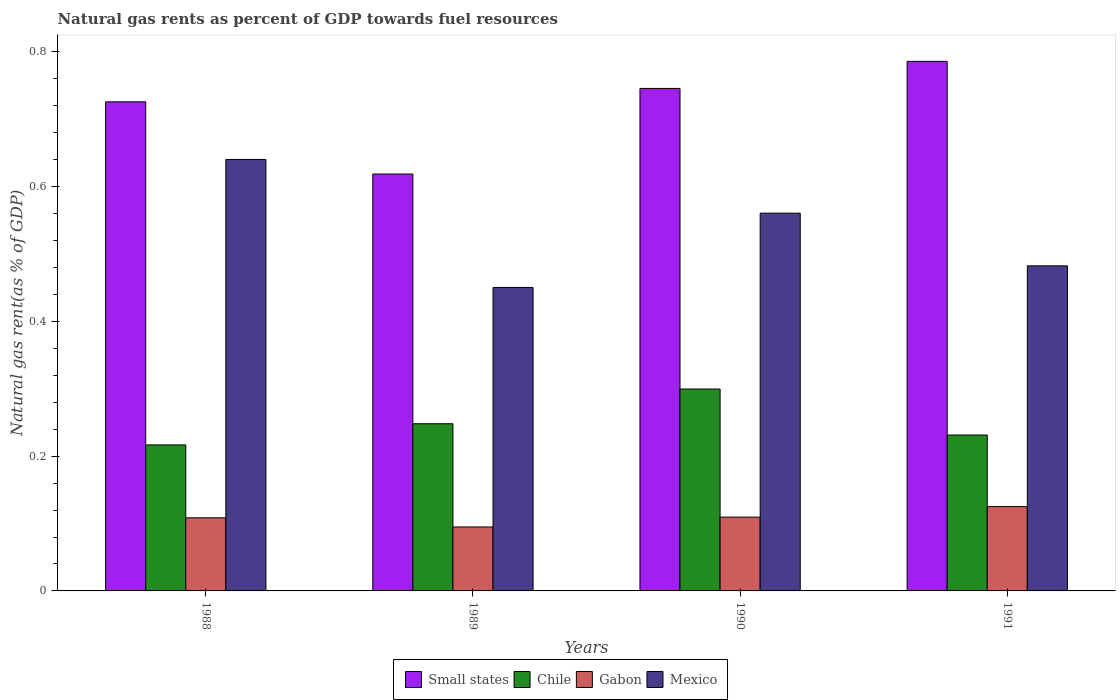How many different coloured bars are there?
Make the answer very short. 4. Are the number of bars per tick equal to the number of legend labels?
Provide a short and direct response. Yes. Are the number of bars on each tick of the X-axis equal?
Your answer should be compact. Yes. How many bars are there on the 2nd tick from the right?
Make the answer very short. 4. What is the natural gas rent in Chile in 1991?
Offer a terse response. 0.23. Across all years, what is the maximum natural gas rent in Mexico?
Your response must be concise. 0.64. Across all years, what is the minimum natural gas rent in Gabon?
Provide a succinct answer. 0.09. In which year was the natural gas rent in Gabon maximum?
Your response must be concise. 1991. In which year was the natural gas rent in Gabon minimum?
Give a very brief answer. 1989. What is the total natural gas rent in Gabon in the graph?
Your answer should be very brief. 0.44. What is the difference between the natural gas rent in Mexico in 1988 and that in 1991?
Your response must be concise. 0.16. What is the difference between the natural gas rent in Small states in 1989 and the natural gas rent in Gabon in 1990?
Offer a very short reply. 0.51. What is the average natural gas rent in Small states per year?
Ensure brevity in your answer.  0.72. In the year 1988, what is the difference between the natural gas rent in Small states and natural gas rent in Chile?
Offer a very short reply. 0.51. In how many years, is the natural gas rent in Chile greater than 0.24000000000000002 %?
Provide a short and direct response. 2. What is the ratio of the natural gas rent in Chile in 1989 to that in 1990?
Offer a very short reply. 0.83. Is the natural gas rent in Gabon in 1988 less than that in 1990?
Your response must be concise. Yes. Is the difference between the natural gas rent in Small states in 1990 and 1991 greater than the difference between the natural gas rent in Chile in 1990 and 1991?
Your response must be concise. No. What is the difference between the highest and the second highest natural gas rent in Mexico?
Give a very brief answer. 0.08. What is the difference between the highest and the lowest natural gas rent in Small states?
Your response must be concise. 0.17. Is the sum of the natural gas rent in Chile in 1990 and 1991 greater than the maximum natural gas rent in Gabon across all years?
Your answer should be compact. Yes. What does the 4th bar from the left in 1989 represents?
Ensure brevity in your answer.  Mexico. What does the 2nd bar from the right in 1988 represents?
Your response must be concise. Gabon. Is it the case that in every year, the sum of the natural gas rent in Chile and natural gas rent in Small states is greater than the natural gas rent in Mexico?
Keep it short and to the point. Yes. Where does the legend appear in the graph?
Give a very brief answer. Bottom center. How many legend labels are there?
Your response must be concise. 4. What is the title of the graph?
Give a very brief answer. Natural gas rents as percent of GDP towards fuel resources. What is the label or title of the Y-axis?
Make the answer very short. Natural gas rent(as % of GDP). What is the Natural gas rent(as % of GDP) of Small states in 1988?
Your answer should be very brief. 0.73. What is the Natural gas rent(as % of GDP) of Chile in 1988?
Provide a succinct answer. 0.22. What is the Natural gas rent(as % of GDP) in Gabon in 1988?
Your response must be concise. 0.11. What is the Natural gas rent(as % of GDP) of Mexico in 1988?
Provide a short and direct response. 0.64. What is the Natural gas rent(as % of GDP) of Small states in 1989?
Give a very brief answer. 0.62. What is the Natural gas rent(as % of GDP) in Chile in 1989?
Provide a succinct answer. 0.25. What is the Natural gas rent(as % of GDP) in Gabon in 1989?
Provide a short and direct response. 0.09. What is the Natural gas rent(as % of GDP) of Mexico in 1989?
Offer a very short reply. 0.45. What is the Natural gas rent(as % of GDP) of Small states in 1990?
Offer a terse response. 0.75. What is the Natural gas rent(as % of GDP) in Chile in 1990?
Give a very brief answer. 0.3. What is the Natural gas rent(as % of GDP) of Gabon in 1990?
Your answer should be compact. 0.11. What is the Natural gas rent(as % of GDP) in Mexico in 1990?
Make the answer very short. 0.56. What is the Natural gas rent(as % of GDP) in Small states in 1991?
Your answer should be very brief. 0.79. What is the Natural gas rent(as % of GDP) of Chile in 1991?
Provide a succinct answer. 0.23. What is the Natural gas rent(as % of GDP) of Gabon in 1991?
Your response must be concise. 0.13. What is the Natural gas rent(as % of GDP) in Mexico in 1991?
Provide a succinct answer. 0.48. Across all years, what is the maximum Natural gas rent(as % of GDP) of Small states?
Give a very brief answer. 0.79. Across all years, what is the maximum Natural gas rent(as % of GDP) in Chile?
Ensure brevity in your answer.  0.3. Across all years, what is the maximum Natural gas rent(as % of GDP) of Gabon?
Offer a terse response. 0.13. Across all years, what is the maximum Natural gas rent(as % of GDP) in Mexico?
Your answer should be very brief. 0.64. Across all years, what is the minimum Natural gas rent(as % of GDP) of Small states?
Ensure brevity in your answer.  0.62. Across all years, what is the minimum Natural gas rent(as % of GDP) in Chile?
Give a very brief answer. 0.22. Across all years, what is the minimum Natural gas rent(as % of GDP) in Gabon?
Your response must be concise. 0.09. Across all years, what is the minimum Natural gas rent(as % of GDP) of Mexico?
Your answer should be compact. 0.45. What is the total Natural gas rent(as % of GDP) of Small states in the graph?
Make the answer very short. 2.88. What is the total Natural gas rent(as % of GDP) in Gabon in the graph?
Ensure brevity in your answer.  0.44. What is the total Natural gas rent(as % of GDP) in Mexico in the graph?
Offer a terse response. 2.13. What is the difference between the Natural gas rent(as % of GDP) of Small states in 1988 and that in 1989?
Make the answer very short. 0.11. What is the difference between the Natural gas rent(as % of GDP) of Chile in 1988 and that in 1989?
Your answer should be compact. -0.03. What is the difference between the Natural gas rent(as % of GDP) in Gabon in 1988 and that in 1989?
Make the answer very short. 0.01. What is the difference between the Natural gas rent(as % of GDP) in Mexico in 1988 and that in 1989?
Your response must be concise. 0.19. What is the difference between the Natural gas rent(as % of GDP) of Small states in 1988 and that in 1990?
Your response must be concise. -0.02. What is the difference between the Natural gas rent(as % of GDP) of Chile in 1988 and that in 1990?
Your response must be concise. -0.08. What is the difference between the Natural gas rent(as % of GDP) in Gabon in 1988 and that in 1990?
Provide a succinct answer. -0. What is the difference between the Natural gas rent(as % of GDP) of Mexico in 1988 and that in 1990?
Keep it short and to the point. 0.08. What is the difference between the Natural gas rent(as % of GDP) in Small states in 1988 and that in 1991?
Ensure brevity in your answer.  -0.06. What is the difference between the Natural gas rent(as % of GDP) of Chile in 1988 and that in 1991?
Your answer should be compact. -0.01. What is the difference between the Natural gas rent(as % of GDP) of Gabon in 1988 and that in 1991?
Provide a succinct answer. -0.02. What is the difference between the Natural gas rent(as % of GDP) in Mexico in 1988 and that in 1991?
Ensure brevity in your answer.  0.16. What is the difference between the Natural gas rent(as % of GDP) in Small states in 1989 and that in 1990?
Offer a very short reply. -0.13. What is the difference between the Natural gas rent(as % of GDP) in Chile in 1989 and that in 1990?
Ensure brevity in your answer.  -0.05. What is the difference between the Natural gas rent(as % of GDP) in Gabon in 1989 and that in 1990?
Provide a succinct answer. -0.01. What is the difference between the Natural gas rent(as % of GDP) in Mexico in 1989 and that in 1990?
Ensure brevity in your answer.  -0.11. What is the difference between the Natural gas rent(as % of GDP) of Small states in 1989 and that in 1991?
Your answer should be very brief. -0.17. What is the difference between the Natural gas rent(as % of GDP) of Chile in 1989 and that in 1991?
Ensure brevity in your answer.  0.02. What is the difference between the Natural gas rent(as % of GDP) of Gabon in 1989 and that in 1991?
Offer a terse response. -0.03. What is the difference between the Natural gas rent(as % of GDP) of Mexico in 1989 and that in 1991?
Your answer should be compact. -0.03. What is the difference between the Natural gas rent(as % of GDP) in Small states in 1990 and that in 1991?
Make the answer very short. -0.04. What is the difference between the Natural gas rent(as % of GDP) in Chile in 1990 and that in 1991?
Provide a succinct answer. 0.07. What is the difference between the Natural gas rent(as % of GDP) of Gabon in 1990 and that in 1991?
Ensure brevity in your answer.  -0.02. What is the difference between the Natural gas rent(as % of GDP) of Mexico in 1990 and that in 1991?
Your response must be concise. 0.08. What is the difference between the Natural gas rent(as % of GDP) in Small states in 1988 and the Natural gas rent(as % of GDP) in Chile in 1989?
Provide a succinct answer. 0.48. What is the difference between the Natural gas rent(as % of GDP) in Small states in 1988 and the Natural gas rent(as % of GDP) in Gabon in 1989?
Offer a very short reply. 0.63. What is the difference between the Natural gas rent(as % of GDP) in Small states in 1988 and the Natural gas rent(as % of GDP) in Mexico in 1989?
Ensure brevity in your answer.  0.28. What is the difference between the Natural gas rent(as % of GDP) of Chile in 1988 and the Natural gas rent(as % of GDP) of Gabon in 1989?
Provide a short and direct response. 0.12. What is the difference between the Natural gas rent(as % of GDP) in Chile in 1988 and the Natural gas rent(as % of GDP) in Mexico in 1989?
Ensure brevity in your answer.  -0.23. What is the difference between the Natural gas rent(as % of GDP) of Gabon in 1988 and the Natural gas rent(as % of GDP) of Mexico in 1989?
Your answer should be compact. -0.34. What is the difference between the Natural gas rent(as % of GDP) in Small states in 1988 and the Natural gas rent(as % of GDP) in Chile in 1990?
Your answer should be very brief. 0.43. What is the difference between the Natural gas rent(as % of GDP) of Small states in 1988 and the Natural gas rent(as % of GDP) of Gabon in 1990?
Offer a very short reply. 0.62. What is the difference between the Natural gas rent(as % of GDP) in Small states in 1988 and the Natural gas rent(as % of GDP) in Mexico in 1990?
Offer a terse response. 0.17. What is the difference between the Natural gas rent(as % of GDP) of Chile in 1988 and the Natural gas rent(as % of GDP) of Gabon in 1990?
Offer a terse response. 0.11. What is the difference between the Natural gas rent(as % of GDP) in Chile in 1988 and the Natural gas rent(as % of GDP) in Mexico in 1990?
Your answer should be very brief. -0.34. What is the difference between the Natural gas rent(as % of GDP) in Gabon in 1988 and the Natural gas rent(as % of GDP) in Mexico in 1990?
Make the answer very short. -0.45. What is the difference between the Natural gas rent(as % of GDP) of Small states in 1988 and the Natural gas rent(as % of GDP) of Chile in 1991?
Offer a very short reply. 0.49. What is the difference between the Natural gas rent(as % of GDP) of Small states in 1988 and the Natural gas rent(as % of GDP) of Gabon in 1991?
Keep it short and to the point. 0.6. What is the difference between the Natural gas rent(as % of GDP) in Small states in 1988 and the Natural gas rent(as % of GDP) in Mexico in 1991?
Give a very brief answer. 0.24. What is the difference between the Natural gas rent(as % of GDP) of Chile in 1988 and the Natural gas rent(as % of GDP) of Gabon in 1991?
Your response must be concise. 0.09. What is the difference between the Natural gas rent(as % of GDP) of Chile in 1988 and the Natural gas rent(as % of GDP) of Mexico in 1991?
Your answer should be very brief. -0.27. What is the difference between the Natural gas rent(as % of GDP) of Gabon in 1988 and the Natural gas rent(as % of GDP) of Mexico in 1991?
Offer a terse response. -0.37. What is the difference between the Natural gas rent(as % of GDP) in Small states in 1989 and the Natural gas rent(as % of GDP) in Chile in 1990?
Make the answer very short. 0.32. What is the difference between the Natural gas rent(as % of GDP) of Small states in 1989 and the Natural gas rent(as % of GDP) of Gabon in 1990?
Give a very brief answer. 0.51. What is the difference between the Natural gas rent(as % of GDP) of Small states in 1989 and the Natural gas rent(as % of GDP) of Mexico in 1990?
Ensure brevity in your answer.  0.06. What is the difference between the Natural gas rent(as % of GDP) in Chile in 1989 and the Natural gas rent(as % of GDP) in Gabon in 1990?
Give a very brief answer. 0.14. What is the difference between the Natural gas rent(as % of GDP) in Chile in 1989 and the Natural gas rent(as % of GDP) in Mexico in 1990?
Your answer should be very brief. -0.31. What is the difference between the Natural gas rent(as % of GDP) of Gabon in 1989 and the Natural gas rent(as % of GDP) of Mexico in 1990?
Your answer should be very brief. -0.47. What is the difference between the Natural gas rent(as % of GDP) of Small states in 1989 and the Natural gas rent(as % of GDP) of Chile in 1991?
Your answer should be very brief. 0.39. What is the difference between the Natural gas rent(as % of GDP) of Small states in 1989 and the Natural gas rent(as % of GDP) of Gabon in 1991?
Offer a terse response. 0.49. What is the difference between the Natural gas rent(as % of GDP) of Small states in 1989 and the Natural gas rent(as % of GDP) of Mexico in 1991?
Offer a very short reply. 0.14. What is the difference between the Natural gas rent(as % of GDP) in Chile in 1989 and the Natural gas rent(as % of GDP) in Gabon in 1991?
Offer a very short reply. 0.12. What is the difference between the Natural gas rent(as % of GDP) of Chile in 1989 and the Natural gas rent(as % of GDP) of Mexico in 1991?
Offer a very short reply. -0.23. What is the difference between the Natural gas rent(as % of GDP) of Gabon in 1989 and the Natural gas rent(as % of GDP) of Mexico in 1991?
Your answer should be compact. -0.39. What is the difference between the Natural gas rent(as % of GDP) of Small states in 1990 and the Natural gas rent(as % of GDP) of Chile in 1991?
Give a very brief answer. 0.51. What is the difference between the Natural gas rent(as % of GDP) of Small states in 1990 and the Natural gas rent(as % of GDP) of Gabon in 1991?
Provide a short and direct response. 0.62. What is the difference between the Natural gas rent(as % of GDP) in Small states in 1990 and the Natural gas rent(as % of GDP) in Mexico in 1991?
Give a very brief answer. 0.26. What is the difference between the Natural gas rent(as % of GDP) of Chile in 1990 and the Natural gas rent(as % of GDP) of Gabon in 1991?
Make the answer very short. 0.17. What is the difference between the Natural gas rent(as % of GDP) of Chile in 1990 and the Natural gas rent(as % of GDP) of Mexico in 1991?
Give a very brief answer. -0.18. What is the difference between the Natural gas rent(as % of GDP) of Gabon in 1990 and the Natural gas rent(as % of GDP) of Mexico in 1991?
Offer a very short reply. -0.37. What is the average Natural gas rent(as % of GDP) in Small states per year?
Offer a terse response. 0.72. What is the average Natural gas rent(as % of GDP) of Chile per year?
Your answer should be very brief. 0.25. What is the average Natural gas rent(as % of GDP) of Gabon per year?
Offer a very short reply. 0.11. What is the average Natural gas rent(as % of GDP) of Mexico per year?
Offer a very short reply. 0.53. In the year 1988, what is the difference between the Natural gas rent(as % of GDP) in Small states and Natural gas rent(as % of GDP) in Chile?
Provide a succinct answer. 0.51. In the year 1988, what is the difference between the Natural gas rent(as % of GDP) of Small states and Natural gas rent(as % of GDP) of Gabon?
Give a very brief answer. 0.62. In the year 1988, what is the difference between the Natural gas rent(as % of GDP) in Small states and Natural gas rent(as % of GDP) in Mexico?
Offer a very short reply. 0.09. In the year 1988, what is the difference between the Natural gas rent(as % of GDP) of Chile and Natural gas rent(as % of GDP) of Gabon?
Keep it short and to the point. 0.11. In the year 1988, what is the difference between the Natural gas rent(as % of GDP) in Chile and Natural gas rent(as % of GDP) in Mexico?
Provide a short and direct response. -0.42. In the year 1988, what is the difference between the Natural gas rent(as % of GDP) of Gabon and Natural gas rent(as % of GDP) of Mexico?
Provide a short and direct response. -0.53. In the year 1989, what is the difference between the Natural gas rent(as % of GDP) in Small states and Natural gas rent(as % of GDP) in Chile?
Offer a terse response. 0.37. In the year 1989, what is the difference between the Natural gas rent(as % of GDP) of Small states and Natural gas rent(as % of GDP) of Gabon?
Provide a short and direct response. 0.52. In the year 1989, what is the difference between the Natural gas rent(as % of GDP) in Small states and Natural gas rent(as % of GDP) in Mexico?
Provide a short and direct response. 0.17. In the year 1989, what is the difference between the Natural gas rent(as % of GDP) of Chile and Natural gas rent(as % of GDP) of Gabon?
Provide a succinct answer. 0.15. In the year 1989, what is the difference between the Natural gas rent(as % of GDP) of Chile and Natural gas rent(as % of GDP) of Mexico?
Offer a terse response. -0.2. In the year 1989, what is the difference between the Natural gas rent(as % of GDP) of Gabon and Natural gas rent(as % of GDP) of Mexico?
Offer a very short reply. -0.36. In the year 1990, what is the difference between the Natural gas rent(as % of GDP) in Small states and Natural gas rent(as % of GDP) in Chile?
Your answer should be compact. 0.45. In the year 1990, what is the difference between the Natural gas rent(as % of GDP) in Small states and Natural gas rent(as % of GDP) in Gabon?
Your answer should be compact. 0.64. In the year 1990, what is the difference between the Natural gas rent(as % of GDP) in Small states and Natural gas rent(as % of GDP) in Mexico?
Your answer should be very brief. 0.19. In the year 1990, what is the difference between the Natural gas rent(as % of GDP) in Chile and Natural gas rent(as % of GDP) in Gabon?
Offer a terse response. 0.19. In the year 1990, what is the difference between the Natural gas rent(as % of GDP) of Chile and Natural gas rent(as % of GDP) of Mexico?
Your answer should be very brief. -0.26. In the year 1990, what is the difference between the Natural gas rent(as % of GDP) of Gabon and Natural gas rent(as % of GDP) of Mexico?
Give a very brief answer. -0.45. In the year 1991, what is the difference between the Natural gas rent(as % of GDP) of Small states and Natural gas rent(as % of GDP) of Chile?
Offer a very short reply. 0.55. In the year 1991, what is the difference between the Natural gas rent(as % of GDP) in Small states and Natural gas rent(as % of GDP) in Gabon?
Your answer should be compact. 0.66. In the year 1991, what is the difference between the Natural gas rent(as % of GDP) of Small states and Natural gas rent(as % of GDP) of Mexico?
Give a very brief answer. 0.3. In the year 1991, what is the difference between the Natural gas rent(as % of GDP) in Chile and Natural gas rent(as % of GDP) in Gabon?
Provide a succinct answer. 0.11. In the year 1991, what is the difference between the Natural gas rent(as % of GDP) in Chile and Natural gas rent(as % of GDP) in Mexico?
Provide a short and direct response. -0.25. In the year 1991, what is the difference between the Natural gas rent(as % of GDP) in Gabon and Natural gas rent(as % of GDP) in Mexico?
Offer a terse response. -0.36. What is the ratio of the Natural gas rent(as % of GDP) in Small states in 1988 to that in 1989?
Ensure brevity in your answer.  1.17. What is the ratio of the Natural gas rent(as % of GDP) of Chile in 1988 to that in 1989?
Make the answer very short. 0.87. What is the ratio of the Natural gas rent(as % of GDP) of Gabon in 1988 to that in 1989?
Provide a succinct answer. 1.14. What is the ratio of the Natural gas rent(as % of GDP) of Mexico in 1988 to that in 1989?
Offer a very short reply. 1.42. What is the ratio of the Natural gas rent(as % of GDP) of Small states in 1988 to that in 1990?
Ensure brevity in your answer.  0.97. What is the ratio of the Natural gas rent(as % of GDP) of Chile in 1988 to that in 1990?
Provide a succinct answer. 0.72. What is the ratio of the Natural gas rent(as % of GDP) in Gabon in 1988 to that in 1990?
Make the answer very short. 0.99. What is the ratio of the Natural gas rent(as % of GDP) of Mexico in 1988 to that in 1990?
Offer a very short reply. 1.14. What is the ratio of the Natural gas rent(as % of GDP) in Small states in 1988 to that in 1991?
Ensure brevity in your answer.  0.92. What is the ratio of the Natural gas rent(as % of GDP) in Chile in 1988 to that in 1991?
Give a very brief answer. 0.94. What is the ratio of the Natural gas rent(as % of GDP) of Gabon in 1988 to that in 1991?
Your response must be concise. 0.87. What is the ratio of the Natural gas rent(as % of GDP) of Mexico in 1988 to that in 1991?
Your response must be concise. 1.33. What is the ratio of the Natural gas rent(as % of GDP) in Small states in 1989 to that in 1990?
Give a very brief answer. 0.83. What is the ratio of the Natural gas rent(as % of GDP) in Chile in 1989 to that in 1990?
Offer a very short reply. 0.83. What is the ratio of the Natural gas rent(as % of GDP) in Gabon in 1989 to that in 1990?
Give a very brief answer. 0.87. What is the ratio of the Natural gas rent(as % of GDP) of Mexico in 1989 to that in 1990?
Your answer should be compact. 0.8. What is the ratio of the Natural gas rent(as % of GDP) of Small states in 1989 to that in 1991?
Provide a succinct answer. 0.79. What is the ratio of the Natural gas rent(as % of GDP) of Chile in 1989 to that in 1991?
Ensure brevity in your answer.  1.07. What is the ratio of the Natural gas rent(as % of GDP) in Gabon in 1989 to that in 1991?
Provide a short and direct response. 0.76. What is the ratio of the Natural gas rent(as % of GDP) of Mexico in 1989 to that in 1991?
Keep it short and to the point. 0.93. What is the ratio of the Natural gas rent(as % of GDP) of Small states in 1990 to that in 1991?
Ensure brevity in your answer.  0.95. What is the ratio of the Natural gas rent(as % of GDP) of Chile in 1990 to that in 1991?
Your response must be concise. 1.29. What is the ratio of the Natural gas rent(as % of GDP) in Gabon in 1990 to that in 1991?
Make the answer very short. 0.88. What is the ratio of the Natural gas rent(as % of GDP) of Mexico in 1990 to that in 1991?
Your response must be concise. 1.16. What is the difference between the highest and the second highest Natural gas rent(as % of GDP) of Small states?
Your answer should be compact. 0.04. What is the difference between the highest and the second highest Natural gas rent(as % of GDP) of Chile?
Offer a very short reply. 0.05. What is the difference between the highest and the second highest Natural gas rent(as % of GDP) of Gabon?
Provide a succinct answer. 0.02. What is the difference between the highest and the second highest Natural gas rent(as % of GDP) in Mexico?
Your answer should be compact. 0.08. What is the difference between the highest and the lowest Natural gas rent(as % of GDP) of Small states?
Provide a succinct answer. 0.17. What is the difference between the highest and the lowest Natural gas rent(as % of GDP) in Chile?
Your response must be concise. 0.08. What is the difference between the highest and the lowest Natural gas rent(as % of GDP) in Gabon?
Ensure brevity in your answer.  0.03. What is the difference between the highest and the lowest Natural gas rent(as % of GDP) of Mexico?
Provide a short and direct response. 0.19. 